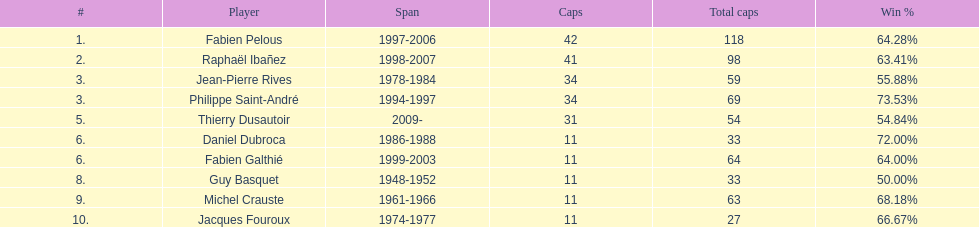How long did michel crauste serve as captain? 1961-1966. 